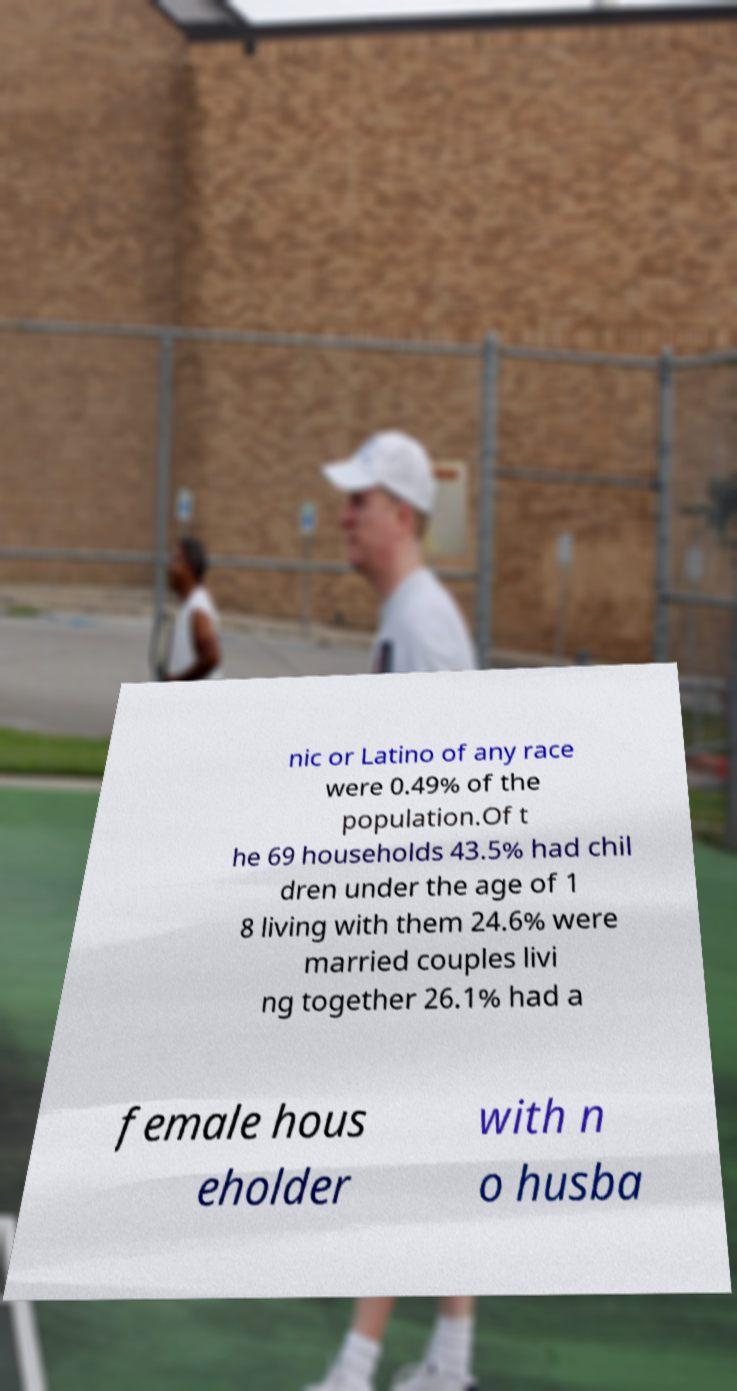What messages or text are displayed in this image? I need them in a readable, typed format. nic or Latino of any race were 0.49% of the population.Of t he 69 households 43.5% had chil dren under the age of 1 8 living with them 24.6% were married couples livi ng together 26.1% had a female hous eholder with n o husba 